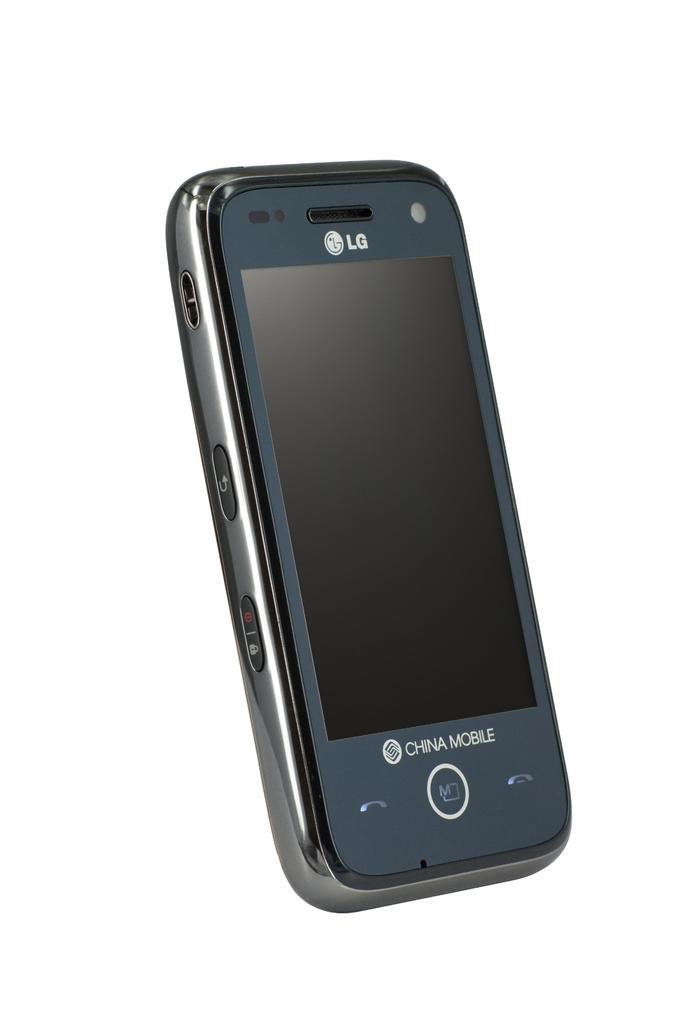<image>
Render a clear and concise summary of the photo. a small black phone that says 'lg china mobile' on it 